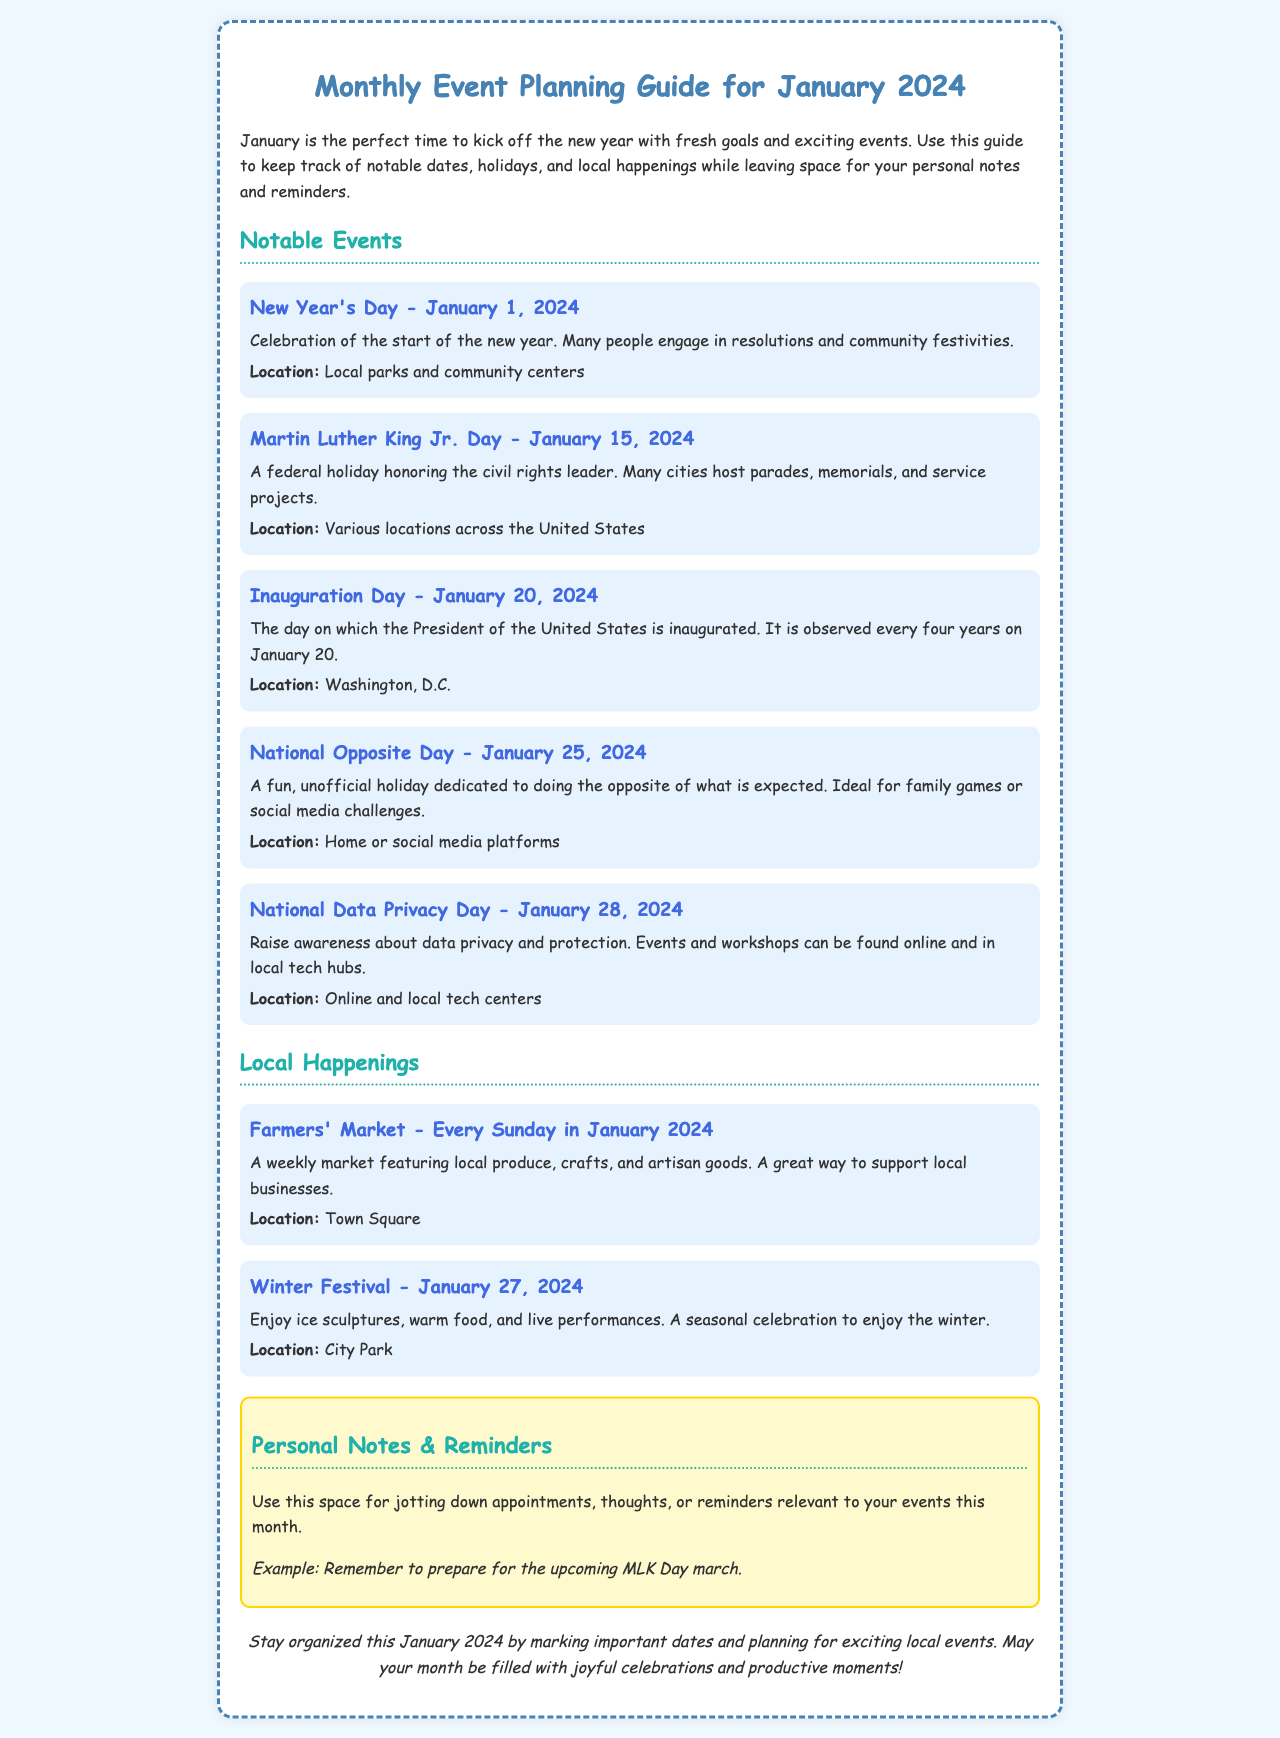What is the title of the brochure? The title of the brochure provides the primary focus and topic of the document.
Answer: Monthly Event Planning Guide for January 2024 What holiday is observed on January 15, 2024? The date is provided along with the holiday's name in the notable events section.
Answer: Martin Luther King Jr. Day Which event occurs on January 20, 2024? This event is highlighted as a significant day in the document, noted alongside its importance.
Answer: Inauguration Day How many events are listed under Notable Events? The total number of events can be calculated by counting the listed events in that section.
Answer: Five What recurring event happens every Sunday in January 2024? The document specifies this local happening and its frequency in the month.
Answer: Farmers' Market What is the location for the Winter Festival? This information is provided in the description of the event to inform where it will take place.
Answer: City Park Which event is dedicated to data privacy awareness? The name of the holiday is indicated along with its purpose in the document.
Answer: National Data Privacy Day What kind of space is provided in the notes section? This section is designated for personal use regarding events and planning.
Answer: Personal Notes & Reminders What is the background color of the brochure? This is a visual detail that adds to the aesthetics of the document.
Answer: Light blue (or the hex code if specified) 